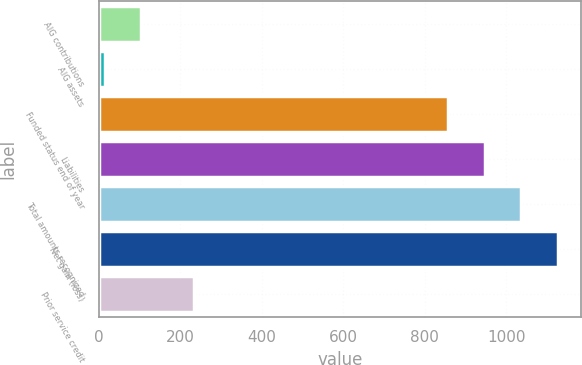Convert chart. <chart><loc_0><loc_0><loc_500><loc_500><bar_chart><fcel>AIG contributions<fcel>AIG assets<fcel>Funded status end of year<fcel>Liabilities<fcel>Total amounts recognized<fcel>Net gain (loss)<fcel>Prior service credit<nl><fcel>103.4<fcel>14<fcel>858<fcel>947.4<fcel>1036.8<fcel>1126.2<fcel>234<nl></chart> 